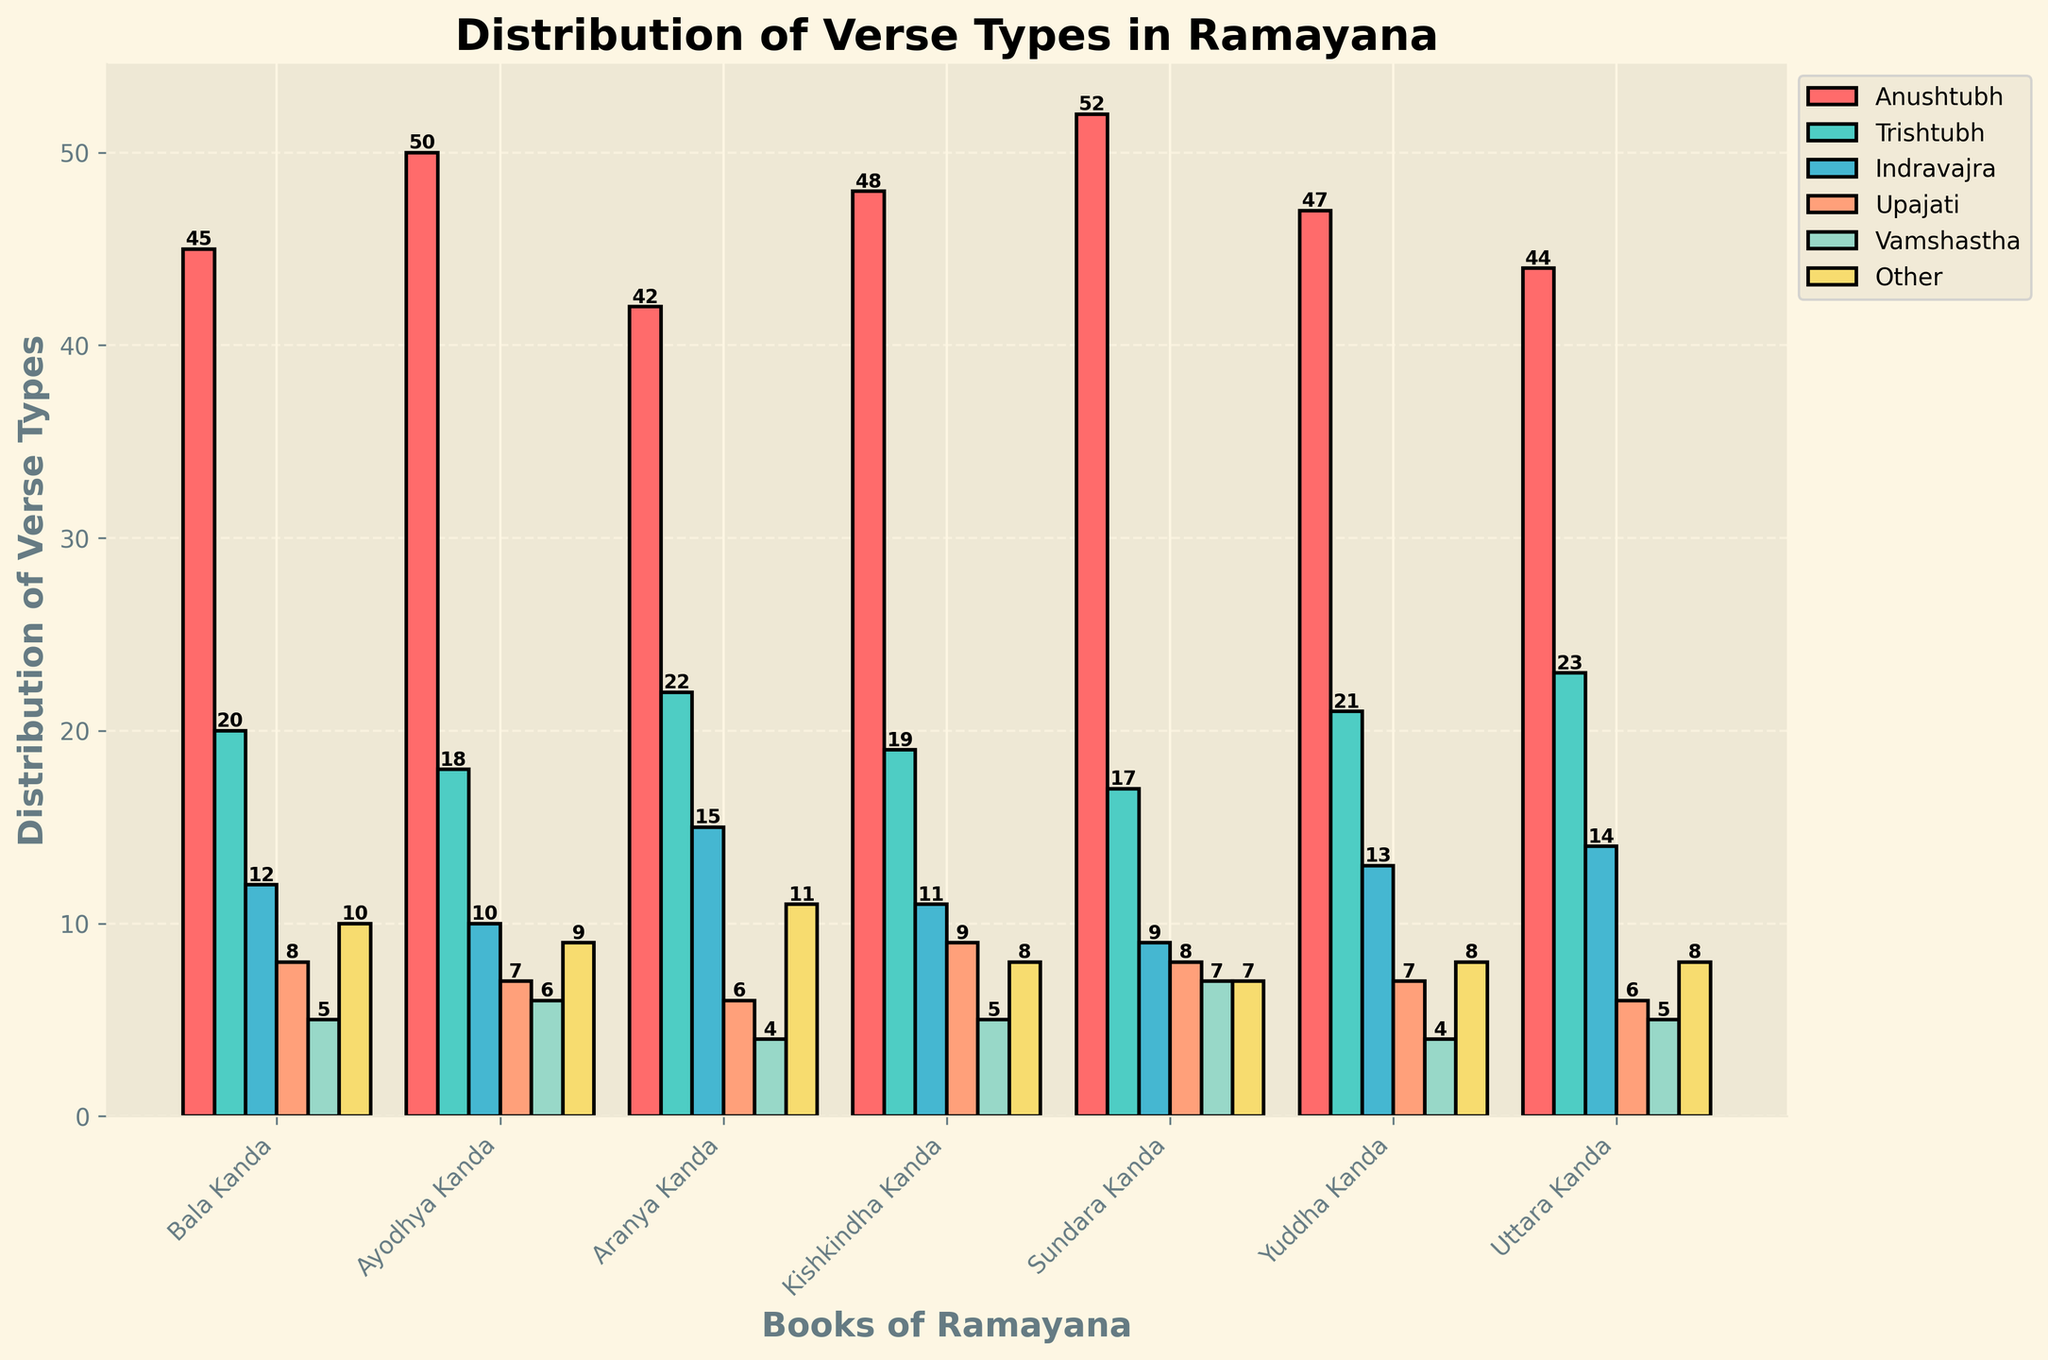Which book has the highest number of Anushtubh verses? To identify the book with the highest number of Anushtubh verses, look at the heights of the bars corresponding to 'Anushtubh' (the first set of bars from the left) for each book. The tallest bar represents the book with the highest value. This book is 'Sundara Kanda'.
Answer: Sundara Kanda Among all the books, in which verse type is the distribution the most consistent? To find the most consistent verse type, observe the variability or consistency in the bar heights for each verse type across all books. 'Other' and 'Upajati' verse types have consistent bar heights, indicating less variability.
Answer: Other / Upajati Which verse type has the tallest single bar across all books? Identify the tallest bar in the plot across all verse types. Visually, it is found in the 'Anushtubh' category for 'Sundara Kanda'.
Answer: Anushtubh Compare the number of Trishtubh and Indravajra verses in Bala Kanda. Which is greater? Look at the bar heights for Trishtubh (second bar) and Indravajra (third bar) in the 'Bala Kanda' category. The number of Trishtubh verses (20) is more than the number of Indravajra verses (12).
Answer: Trishtubh What is the total number of Upajati verses in Sundara Kanda and Yuddha Kanda combined? Sum the Upajati bar heights for 'Sundara Kanda' and 'Yuddha Kanda’. Sundara Kanda has 8 and Yuddha Kanda has 7, totaling 15.
Answer: 15 Which book has the least number of Other verses? Compare the heights of the 'Other' (last set of bars) across all books. The smallest bar is in 'Sundara Kanda', which has 7 verses.
Answer: Sundara Kanda What is the difference in the number of Vamshastha verses between Kishkindha Kanda and Ayodhya Kanda? Subtract the number of Vamshastha verses in 'Ayodhya Kanda' (6) from the number in 'Kishkindha Kanda' (5). The difference is 1.
Answer: 1 In which book is the difference between the number of Trishtubh and Anushtubh verses the greatest? Subtract the number of Trishtubh from Anushtubh in each book and compare. The largest difference is found in 'Sundara Kanda' with a difference of 35 (52 - 17).
Answer: Sundara Kanda What is the average number of Upajati verses per book? Sum the Upajati verses in all books (8+7+6+9+8+7+6 = 51) and divide by the number of books (7). 51 divided by 7 is approximately 7.29.
Answer: 7.29 